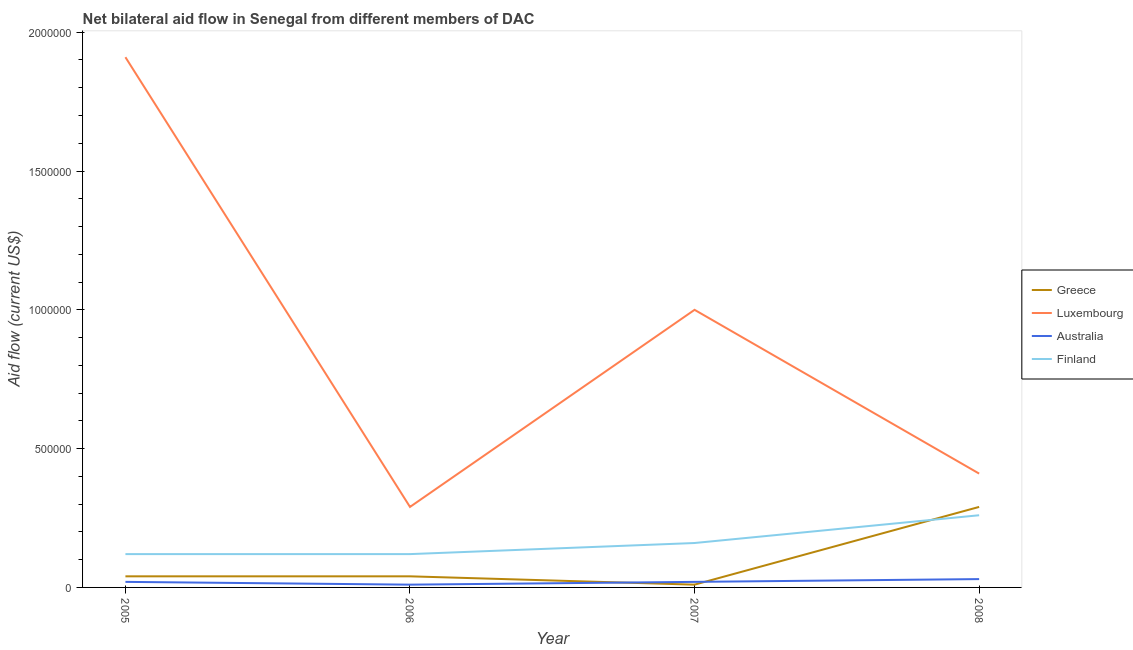Is the number of lines equal to the number of legend labels?
Your answer should be very brief. Yes. What is the amount of aid given by australia in 2007?
Provide a succinct answer. 2.00e+04. Across all years, what is the maximum amount of aid given by luxembourg?
Give a very brief answer. 1.91e+06. Across all years, what is the minimum amount of aid given by luxembourg?
Provide a succinct answer. 2.90e+05. In which year was the amount of aid given by greece minimum?
Provide a succinct answer. 2007. What is the total amount of aid given by finland in the graph?
Make the answer very short. 6.60e+05. What is the difference between the amount of aid given by australia in 2006 and that in 2007?
Provide a succinct answer. -10000. What is the difference between the amount of aid given by finland in 2005 and the amount of aid given by greece in 2008?
Provide a short and direct response. -1.70e+05. What is the average amount of aid given by luxembourg per year?
Your answer should be compact. 9.02e+05. In the year 2005, what is the difference between the amount of aid given by finland and amount of aid given by australia?
Provide a succinct answer. 1.00e+05. In how many years, is the amount of aid given by greece greater than 1300000 US$?
Your answer should be compact. 0. What is the ratio of the amount of aid given by greece in 2005 to that in 2008?
Offer a very short reply. 0.14. Is the amount of aid given by luxembourg in 2006 less than that in 2008?
Ensure brevity in your answer.  Yes. Is the difference between the amount of aid given by australia in 2005 and 2006 greater than the difference between the amount of aid given by greece in 2005 and 2006?
Provide a succinct answer. Yes. What is the difference between the highest and the second highest amount of aid given by luxembourg?
Your response must be concise. 9.10e+05. What is the difference between the highest and the lowest amount of aid given by finland?
Give a very brief answer. 1.40e+05. In how many years, is the amount of aid given by australia greater than the average amount of aid given by australia taken over all years?
Keep it short and to the point. 1. Is the sum of the amount of aid given by finland in 2006 and 2007 greater than the maximum amount of aid given by greece across all years?
Give a very brief answer. No. Is it the case that in every year, the sum of the amount of aid given by finland and amount of aid given by australia is greater than the sum of amount of aid given by luxembourg and amount of aid given by greece?
Provide a short and direct response. Yes. How many lines are there?
Your answer should be very brief. 4. What is the difference between two consecutive major ticks on the Y-axis?
Offer a terse response. 5.00e+05. Are the values on the major ticks of Y-axis written in scientific E-notation?
Your answer should be compact. No. Does the graph contain any zero values?
Make the answer very short. No. Does the graph contain grids?
Make the answer very short. No. How many legend labels are there?
Your answer should be compact. 4. How are the legend labels stacked?
Your response must be concise. Vertical. What is the title of the graph?
Ensure brevity in your answer.  Net bilateral aid flow in Senegal from different members of DAC. What is the label or title of the X-axis?
Your answer should be compact. Year. What is the label or title of the Y-axis?
Keep it short and to the point. Aid flow (current US$). What is the Aid flow (current US$) in Greece in 2005?
Give a very brief answer. 4.00e+04. What is the Aid flow (current US$) in Luxembourg in 2005?
Your answer should be very brief. 1.91e+06. What is the Aid flow (current US$) of Australia in 2005?
Your answer should be compact. 2.00e+04. What is the Aid flow (current US$) of Greece in 2006?
Provide a succinct answer. 4.00e+04. What is the Aid flow (current US$) in Luxembourg in 2006?
Give a very brief answer. 2.90e+05. What is the Aid flow (current US$) in Finland in 2006?
Ensure brevity in your answer.  1.20e+05. What is the Aid flow (current US$) in Greece in 2007?
Provide a short and direct response. 10000. What is the Aid flow (current US$) in Luxembourg in 2007?
Ensure brevity in your answer.  1.00e+06. What is the Aid flow (current US$) of Finland in 2007?
Your answer should be compact. 1.60e+05. What is the Aid flow (current US$) in Luxembourg in 2008?
Make the answer very short. 4.10e+05. Across all years, what is the maximum Aid flow (current US$) in Greece?
Your response must be concise. 2.90e+05. Across all years, what is the maximum Aid flow (current US$) in Luxembourg?
Give a very brief answer. 1.91e+06. Across all years, what is the maximum Aid flow (current US$) of Australia?
Provide a succinct answer. 3.00e+04. Across all years, what is the minimum Aid flow (current US$) of Greece?
Ensure brevity in your answer.  10000. Across all years, what is the minimum Aid flow (current US$) in Finland?
Keep it short and to the point. 1.20e+05. What is the total Aid flow (current US$) of Luxembourg in the graph?
Make the answer very short. 3.61e+06. What is the total Aid flow (current US$) of Australia in the graph?
Give a very brief answer. 8.00e+04. What is the difference between the Aid flow (current US$) of Luxembourg in 2005 and that in 2006?
Provide a succinct answer. 1.62e+06. What is the difference between the Aid flow (current US$) of Australia in 2005 and that in 2006?
Your answer should be compact. 10000. What is the difference between the Aid flow (current US$) in Finland in 2005 and that in 2006?
Offer a very short reply. 0. What is the difference between the Aid flow (current US$) of Luxembourg in 2005 and that in 2007?
Offer a terse response. 9.10e+05. What is the difference between the Aid flow (current US$) of Australia in 2005 and that in 2007?
Offer a terse response. 0. What is the difference between the Aid flow (current US$) of Luxembourg in 2005 and that in 2008?
Provide a succinct answer. 1.50e+06. What is the difference between the Aid flow (current US$) of Australia in 2005 and that in 2008?
Give a very brief answer. -10000. What is the difference between the Aid flow (current US$) in Greece in 2006 and that in 2007?
Ensure brevity in your answer.  3.00e+04. What is the difference between the Aid flow (current US$) in Luxembourg in 2006 and that in 2007?
Provide a succinct answer. -7.10e+05. What is the difference between the Aid flow (current US$) in Australia in 2006 and that in 2007?
Give a very brief answer. -10000. What is the difference between the Aid flow (current US$) of Finland in 2006 and that in 2007?
Provide a short and direct response. -4.00e+04. What is the difference between the Aid flow (current US$) in Luxembourg in 2006 and that in 2008?
Keep it short and to the point. -1.20e+05. What is the difference between the Aid flow (current US$) of Finland in 2006 and that in 2008?
Keep it short and to the point. -1.40e+05. What is the difference between the Aid flow (current US$) of Greece in 2007 and that in 2008?
Ensure brevity in your answer.  -2.80e+05. What is the difference between the Aid flow (current US$) of Luxembourg in 2007 and that in 2008?
Offer a terse response. 5.90e+05. What is the difference between the Aid flow (current US$) of Australia in 2007 and that in 2008?
Make the answer very short. -10000. What is the difference between the Aid flow (current US$) of Greece in 2005 and the Aid flow (current US$) of Finland in 2006?
Ensure brevity in your answer.  -8.00e+04. What is the difference between the Aid flow (current US$) of Luxembourg in 2005 and the Aid flow (current US$) of Australia in 2006?
Keep it short and to the point. 1.90e+06. What is the difference between the Aid flow (current US$) in Luxembourg in 2005 and the Aid flow (current US$) in Finland in 2006?
Your answer should be very brief. 1.79e+06. What is the difference between the Aid flow (current US$) of Greece in 2005 and the Aid flow (current US$) of Luxembourg in 2007?
Provide a succinct answer. -9.60e+05. What is the difference between the Aid flow (current US$) in Greece in 2005 and the Aid flow (current US$) in Finland in 2007?
Your response must be concise. -1.20e+05. What is the difference between the Aid flow (current US$) in Luxembourg in 2005 and the Aid flow (current US$) in Australia in 2007?
Make the answer very short. 1.89e+06. What is the difference between the Aid flow (current US$) in Luxembourg in 2005 and the Aid flow (current US$) in Finland in 2007?
Your response must be concise. 1.75e+06. What is the difference between the Aid flow (current US$) of Greece in 2005 and the Aid flow (current US$) of Luxembourg in 2008?
Your answer should be very brief. -3.70e+05. What is the difference between the Aid flow (current US$) of Greece in 2005 and the Aid flow (current US$) of Australia in 2008?
Offer a terse response. 10000. What is the difference between the Aid flow (current US$) in Luxembourg in 2005 and the Aid flow (current US$) in Australia in 2008?
Offer a terse response. 1.88e+06. What is the difference between the Aid flow (current US$) of Luxembourg in 2005 and the Aid flow (current US$) of Finland in 2008?
Offer a very short reply. 1.65e+06. What is the difference between the Aid flow (current US$) of Australia in 2005 and the Aid flow (current US$) of Finland in 2008?
Your answer should be very brief. -2.40e+05. What is the difference between the Aid flow (current US$) of Greece in 2006 and the Aid flow (current US$) of Luxembourg in 2007?
Offer a terse response. -9.60e+05. What is the difference between the Aid flow (current US$) in Luxembourg in 2006 and the Aid flow (current US$) in Australia in 2007?
Provide a succinct answer. 2.70e+05. What is the difference between the Aid flow (current US$) in Luxembourg in 2006 and the Aid flow (current US$) in Finland in 2007?
Make the answer very short. 1.30e+05. What is the difference between the Aid flow (current US$) of Australia in 2006 and the Aid flow (current US$) of Finland in 2007?
Offer a very short reply. -1.50e+05. What is the difference between the Aid flow (current US$) in Greece in 2006 and the Aid flow (current US$) in Luxembourg in 2008?
Make the answer very short. -3.70e+05. What is the difference between the Aid flow (current US$) of Luxembourg in 2006 and the Aid flow (current US$) of Australia in 2008?
Offer a terse response. 2.60e+05. What is the difference between the Aid flow (current US$) in Luxembourg in 2006 and the Aid flow (current US$) in Finland in 2008?
Provide a short and direct response. 3.00e+04. What is the difference between the Aid flow (current US$) in Australia in 2006 and the Aid flow (current US$) in Finland in 2008?
Your answer should be compact. -2.50e+05. What is the difference between the Aid flow (current US$) in Greece in 2007 and the Aid flow (current US$) in Luxembourg in 2008?
Your answer should be compact. -4.00e+05. What is the difference between the Aid flow (current US$) of Greece in 2007 and the Aid flow (current US$) of Finland in 2008?
Provide a short and direct response. -2.50e+05. What is the difference between the Aid flow (current US$) of Luxembourg in 2007 and the Aid flow (current US$) of Australia in 2008?
Offer a very short reply. 9.70e+05. What is the difference between the Aid flow (current US$) in Luxembourg in 2007 and the Aid flow (current US$) in Finland in 2008?
Provide a short and direct response. 7.40e+05. What is the difference between the Aid flow (current US$) in Australia in 2007 and the Aid flow (current US$) in Finland in 2008?
Your response must be concise. -2.40e+05. What is the average Aid flow (current US$) in Greece per year?
Your answer should be compact. 9.50e+04. What is the average Aid flow (current US$) in Luxembourg per year?
Your answer should be compact. 9.02e+05. What is the average Aid flow (current US$) in Finland per year?
Provide a succinct answer. 1.65e+05. In the year 2005, what is the difference between the Aid flow (current US$) in Greece and Aid flow (current US$) in Luxembourg?
Provide a short and direct response. -1.87e+06. In the year 2005, what is the difference between the Aid flow (current US$) in Luxembourg and Aid flow (current US$) in Australia?
Offer a terse response. 1.89e+06. In the year 2005, what is the difference between the Aid flow (current US$) of Luxembourg and Aid flow (current US$) of Finland?
Give a very brief answer. 1.79e+06. In the year 2005, what is the difference between the Aid flow (current US$) in Australia and Aid flow (current US$) in Finland?
Make the answer very short. -1.00e+05. In the year 2006, what is the difference between the Aid flow (current US$) of Greece and Aid flow (current US$) of Luxembourg?
Your response must be concise. -2.50e+05. In the year 2006, what is the difference between the Aid flow (current US$) in Australia and Aid flow (current US$) in Finland?
Your response must be concise. -1.10e+05. In the year 2007, what is the difference between the Aid flow (current US$) in Greece and Aid flow (current US$) in Luxembourg?
Your answer should be very brief. -9.90e+05. In the year 2007, what is the difference between the Aid flow (current US$) in Greece and Aid flow (current US$) in Australia?
Provide a succinct answer. -10000. In the year 2007, what is the difference between the Aid flow (current US$) in Greece and Aid flow (current US$) in Finland?
Your answer should be very brief. -1.50e+05. In the year 2007, what is the difference between the Aid flow (current US$) of Luxembourg and Aid flow (current US$) of Australia?
Provide a succinct answer. 9.80e+05. In the year 2007, what is the difference between the Aid flow (current US$) of Luxembourg and Aid flow (current US$) of Finland?
Ensure brevity in your answer.  8.40e+05. In the year 2007, what is the difference between the Aid flow (current US$) in Australia and Aid flow (current US$) in Finland?
Keep it short and to the point. -1.40e+05. In the year 2008, what is the difference between the Aid flow (current US$) in Greece and Aid flow (current US$) in Australia?
Your response must be concise. 2.60e+05. In the year 2008, what is the difference between the Aid flow (current US$) of Luxembourg and Aid flow (current US$) of Finland?
Your response must be concise. 1.50e+05. What is the ratio of the Aid flow (current US$) of Luxembourg in 2005 to that in 2006?
Ensure brevity in your answer.  6.59. What is the ratio of the Aid flow (current US$) in Australia in 2005 to that in 2006?
Make the answer very short. 2. What is the ratio of the Aid flow (current US$) of Finland in 2005 to that in 2006?
Offer a very short reply. 1. What is the ratio of the Aid flow (current US$) in Greece in 2005 to that in 2007?
Offer a terse response. 4. What is the ratio of the Aid flow (current US$) in Luxembourg in 2005 to that in 2007?
Your response must be concise. 1.91. What is the ratio of the Aid flow (current US$) of Australia in 2005 to that in 2007?
Give a very brief answer. 1. What is the ratio of the Aid flow (current US$) of Greece in 2005 to that in 2008?
Give a very brief answer. 0.14. What is the ratio of the Aid flow (current US$) of Luxembourg in 2005 to that in 2008?
Ensure brevity in your answer.  4.66. What is the ratio of the Aid flow (current US$) of Australia in 2005 to that in 2008?
Provide a succinct answer. 0.67. What is the ratio of the Aid flow (current US$) of Finland in 2005 to that in 2008?
Offer a very short reply. 0.46. What is the ratio of the Aid flow (current US$) in Greece in 2006 to that in 2007?
Offer a terse response. 4. What is the ratio of the Aid flow (current US$) in Luxembourg in 2006 to that in 2007?
Keep it short and to the point. 0.29. What is the ratio of the Aid flow (current US$) of Australia in 2006 to that in 2007?
Keep it short and to the point. 0.5. What is the ratio of the Aid flow (current US$) in Greece in 2006 to that in 2008?
Your response must be concise. 0.14. What is the ratio of the Aid flow (current US$) in Luxembourg in 2006 to that in 2008?
Provide a succinct answer. 0.71. What is the ratio of the Aid flow (current US$) of Finland in 2006 to that in 2008?
Keep it short and to the point. 0.46. What is the ratio of the Aid flow (current US$) in Greece in 2007 to that in 2008?
Ensure brevity in your answer.  0.03. What is the ratio of the Aid flow (current US$) in Luxembourg in 2007 to that in 2008?
Offer a terse response. 2.44. What is the ratio of the Aid flow (current US$) of Australia in 2007 to that in 2008?
Give a very brief answer. 0.67. What is the ratio of the Aid flow (current US$) in Finland in 2007 to that in 2008?
Provide a succinct answer. 0.62. What is the difference between the highest and the second highest Aid flow (current US$) in Greece?
Your response must be concise. 2.50e+05. What is the difference between the highest and the second highest Aid flow (current US$) of Luxembourg?
Provide a succinct answer. 9.10e+05. What is the difference between the highest and the lowest Aid flow (current US$) in Greece?
Offer a very short reply. 2.80e+05. What is the difference between the highest and the lowest Aid flow (current US$) of Luxembourg?
Offer a very short reply. 1.62e+06. What is the difference between the highest and the lowest Aid flow (current US$) in Finland?
Offer a terse response. 1.40e+05. 